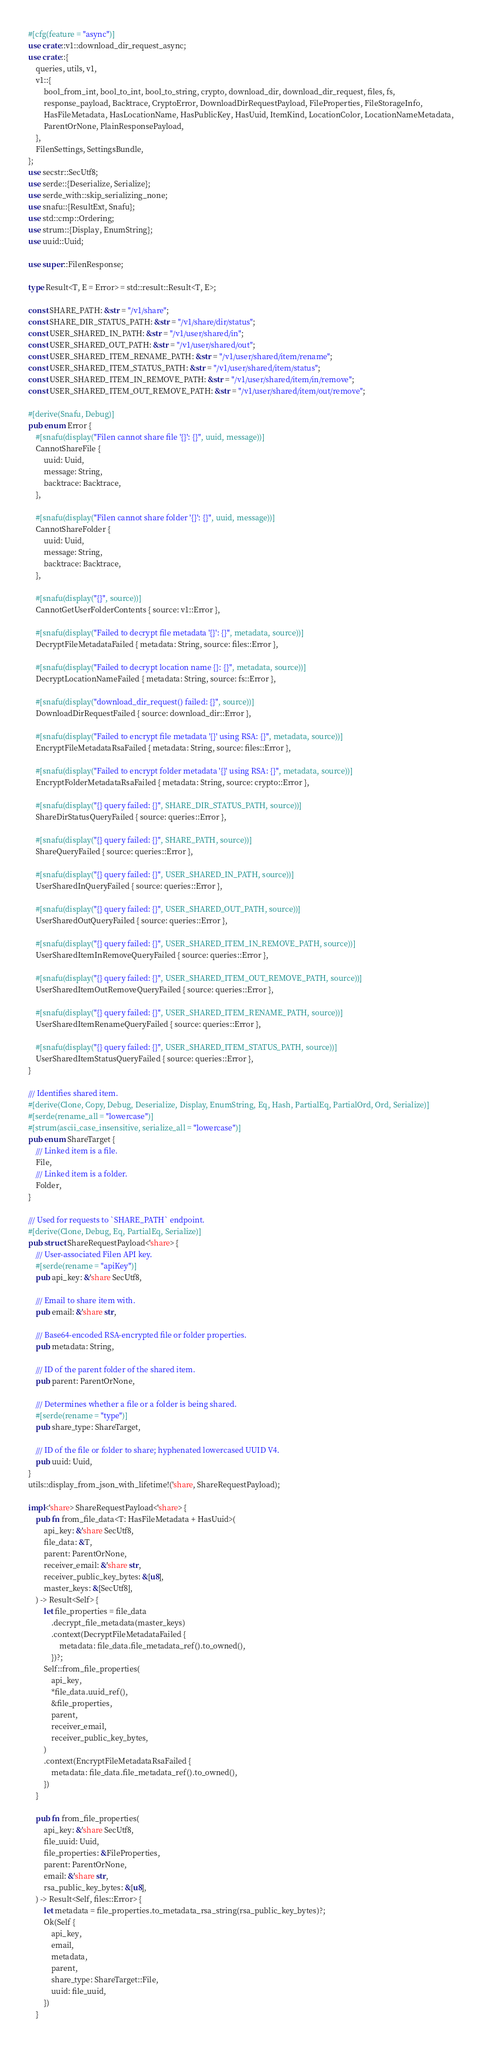<code> <loc_0><loc_0><loc_500><loc_500><_Rust_>#[cfg(feature = "async")]
use crate::v1::download_dir_request_async;
use crate::{
    queries, utils, v1,
    v1::{
        bool_from_int, bool_to_int, bool_to_string, crypto, download_dir, download_dir_request, files, fs,
        response_payload, Backtrace, CryptoError, DownloadDirRequestPayload, FileProperties, FileStorageInfo,
        HasFileMetadata, HasLocationName, HasPublicKey, HasUuid, ItemKind, LocationColor, LocationNameMetadata,
        ParentOrNone, PlainResponsePayload,
    },
    FilenSettings, SettingsBundle,
};
use secstr::SecUtf8;
use serde::{Deserialize, Serialize};
use serde_with::skip_serializing_none;
use snafu::{ResultExt, Snafu};
use std::cmp::Ordering;
use strum::{Display, EnumString};
use uuid::Uuid;

use super::FilenResponse;

type Result<T, E = Error> = std::result::Result<T, E>;

const SHARE_PATH: &str = "/v1/share";
const SHARE_DIR_STATUS_PATH: &str = "/v1/share/dir/status";
const USER_SHARED_IN_PATH: &str = "/v1/user/shared/in";
const USER_SHARED_OUT_PATH: &str = "/v1/user/shared/out";
const USER_SHARED_ITEM_RENAME_PATH: &str = "/v1/user/shared/item/rename";
const USER_SHARED_ITEM_STATUS_PATH: &str = "/v1/user/shared/item/status";
const USER_SHARED_ITEM_IN_REMOVE_PATH: &str = "/v1/user/shared/item/in/remove";
const USER_SHARED_ITEM_OUT_REMOVE_PATH: &str = "/v1/user/shared/item/out/remove";

#[derive(Snafu, Debug)]
pub enum Error {
    #[snafu(display("Filen cannot share file '{}': {}", uuid, message))]
    CannotShareFile {
        uuid: Uuid,
        message: String,
        backtrace: Backtrace,
    },

    #[snafu(display("Filen cannot share folder '{}': {}", uuid, message))]
    CannotShareFolder {
        uuid: Uuid,
        message: String,
        backtrace: Backtrace,
    },

    #[snafu(display("{}", source))]
    CannotGetUserFolderContents { source: v1::Error },

    #[snafu(display("Failed to decrypt file metadata '{}': {}", metadata, source))]
    DecryptFileMetadataFailed { metadata: String, source: files::Error },

    #[snafu(display("Failed to decrypt location name {}: {}", metadata, source))]
    DecryptLocationNameFailed { metadata: String, source: fs::Error },

    #[snafu(display("download_dir_request() failed: {}", source))]
    DownloadDirRequestFailed { source: download_dir::Error },

    #[snafu(display("Failed to encrypt file metadata '{}' using RSA: {}", metadata, source))]
    EncryptFileMetadataRsaFailed { metadata: String, source: files::Error },

    #[snafu(display("Failed to encrypt folder metadata '{}' using RSA: {}", metadata, source))]
    EncryptFolderMetadataRsaFailed { metadata: String, source: crypto::Error },

    #[snafu(display("{} query failed: {}", SHARE_DIR_STATUS_PATH, source))]
    ShareDirStatusQueryFailed { source: queries::Error },

    #[snafu(display("{} query failed: {}", SHARE_PATH, source))]
    ShareQueryFailed { source: queries::Error },

    #[snafu(display("{} query failed: {}", USER_SHARED_IN_PATH, source))]
    UserSharedInQueryFailed { source: queries::Error },

    #[snafu(display("{} query failed: {}", USER_SHARED_OUT_PATH, source))]
    UserSharedOutQueryFailed { source: queries::Error },

    #[snafu(display("{} query failed: {}", USER_SHARED_ITEM_IN_REMOVE_PATH, source))]
    UserSharedItemInRemoveQueryFailed { source: queries::Error },

    #[snafu(display("{} query failed: {}", USER_SHARED_ITEM_OUT_REMOVE_PATH, source))]
    UserSharedItemOutRemoveQueryFailed { source: queries::Error },

    #[snafu(display("{} query failed: {}", USER_SHARED_ITEM_RENAME_PATH, source))]
    UserSharedItemRenameQueryFailed { source: queries::Error },

    #[snafu(display("{} query failed: {}", USER_SHARED_ITEM_STATUS_PATH, source))]
    UserSharedItemStatusQueryFailed { source: queries::Error },
}

/// Identifies shared item.
#[derive(Clone, Copy, Debug, Deserialize, Display, EnumString, Eq, Hash, PartialEq, PartialOrd, Ord, Serialize)]
#[serde(rename_all = "lowercase")]
#[strum(ascii_case_insensitive, serialize_all = "lowercase")]
pub enum ShareTarget {
    /// Linked item is a file.
    File,
    /// Linked item is a folder.
    Folder,
}

/// Used for requests to `SHARE_PATH` endpoint.
#[derive(Clone, Debug, Eq, PartialEq, Serialize)]
pub struct ShareRequestPayload<'share> {
    /// User-associated Filen API key.
    #[serde(rename = "apiKey")]
    pub api_key: &'share SecUtf8,

    /// Email to share item with.
    pub email: &'share str,

    /// Base64-encoded RSA-encrypted file or folder properties.
    pub metadata: String,

    /// ID of the parent folder of the shared item.
    pub parent: ParentOrNone,

    /// Determines whether a file or a folder is being shared.
    #[serde(rename = "type")]
    pub share_type: ShareTarget,

    /// ID of the file or folder to share; hyphenated lowercased UUID V4.
    pub uuid: Uuid,
}
utils::display_from_json_with_lifetime!('share, ShareRequestPayload);

impl<'share> ShareRequestPayload<'share> {
    pub fn from_file_data<T: HasFileMetadata + HasUuid>(
        api_key: &'share SecUtf8,
        file_data: &T,
        parent: ParentOrNone,
        receiver_email: &'share str,
        receiver_public_key_bytes: &[u8],
        master_keys: &[SecUtf8],
    ) -> Result<Self> {
        let file_properties = file_data
            .decrypt_file_metadata(master_keys)
            .context(DecryptFileMetadataFailed {
                metadata: file_data.file_metadata_ref().to_owned(),
            })?;
        Self::from_file_properties(
            api_key,
            *file_data.uuid_ref(),
            &file_properties,
            parent,
            receiver_email,
            receiver_public_key_bytes,
        )
        .context(EncryptFileMetadataRsaFailed {
            metadata: file_data.file_metadata_ref().to_owned(),
        })
    }

    pub fn from_file_properties(
        api_key: &'share SecUtf8,
        file_uuid: Uuid,
        file_properties: &FileProperties,
        parent: ParentOrNone,
        email: &'share str,
        rsa_public_key_bytes: &[u8],
    ) -> Result<Self, files::Error> {
        let metadata = file_properties.to_metadata_rsa_string(rsa_public_key_bytes)?;
        Ok(Self {
            api_key,
            email,
            metadata,
            parent,
            share_type: ShareTarget::File,
            uuid: file_uuid,
        })
    }
</code> 